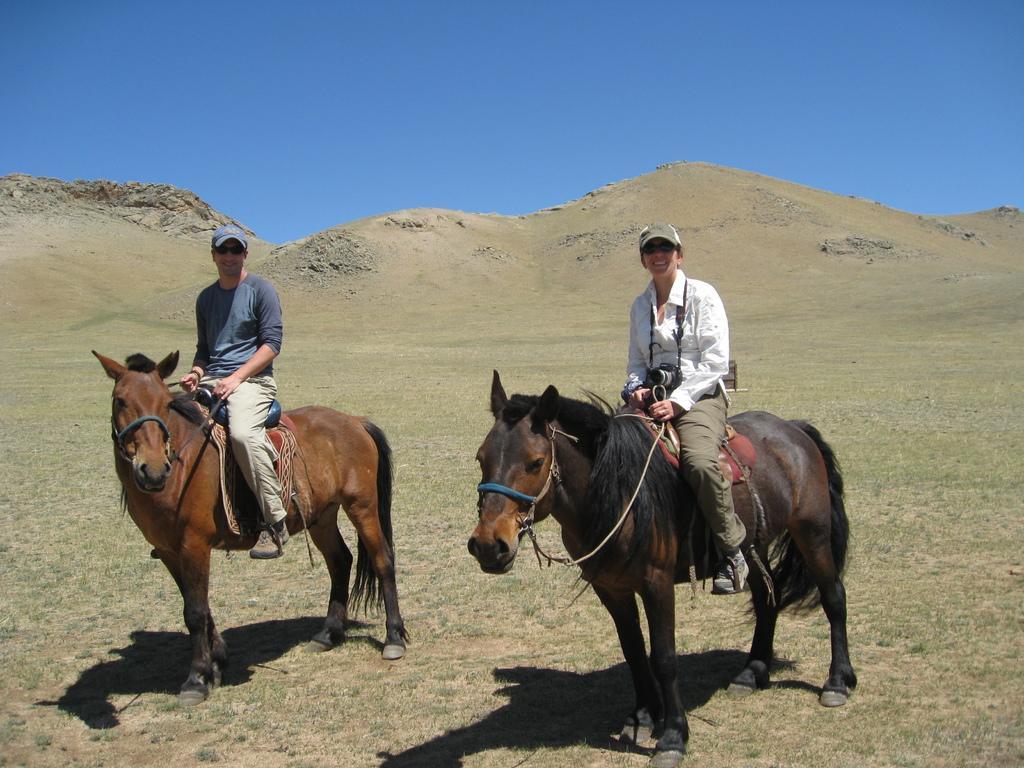Describe this image in one or two sentences. In this image we can see 2 people on horses. And we can see people holding cameras. And we can see the hill. And we can see the sky. 